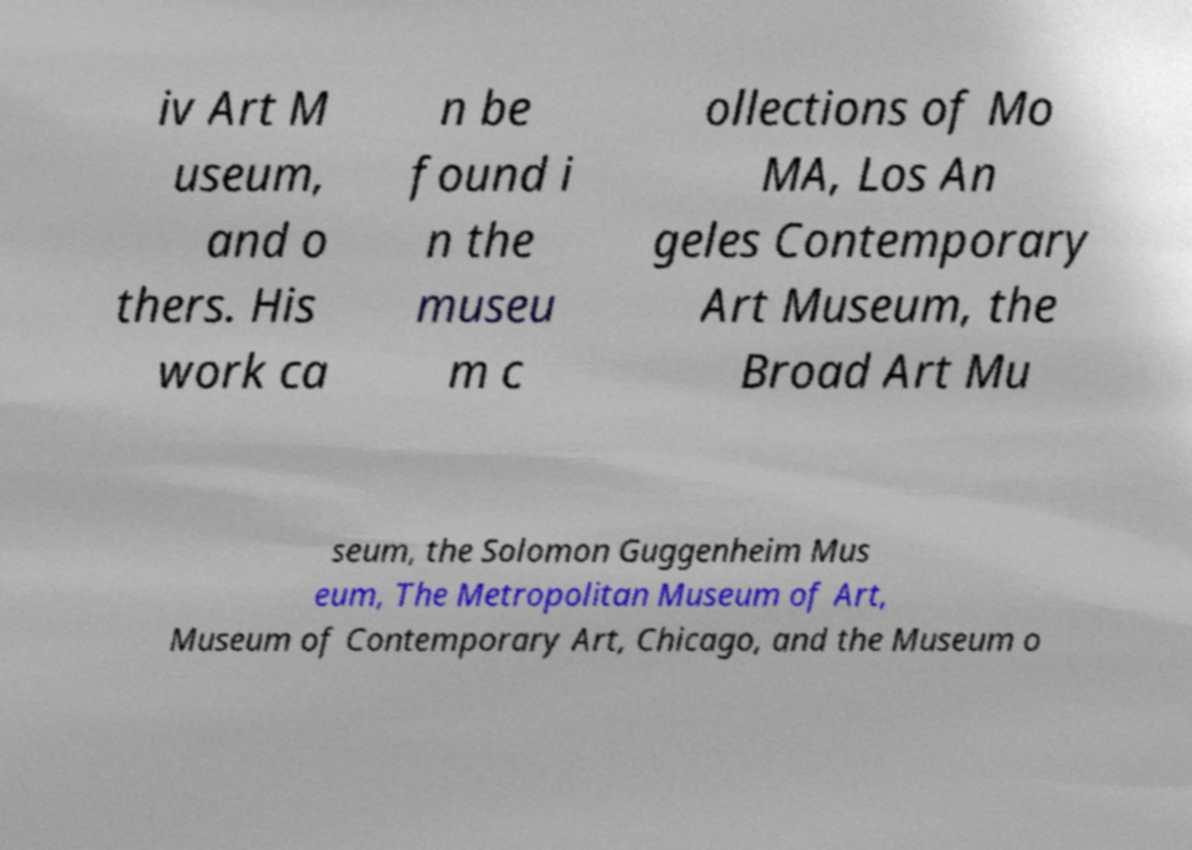Can you read and provide the text displayed in the image?This photo seems to have some interesting text. Can you extract and type it out for me? iv Art M useum, and o thers. His work ca n be found i n the museu m c ollections of Mo MA, Los An geles Contemporary Art Museum, the Broad Art Mu seum, the Solomon Guggenheim Mus eum, The Metropolitan Museum of Art, Museum of Contemporary Art, Chicago, and the Museum o 